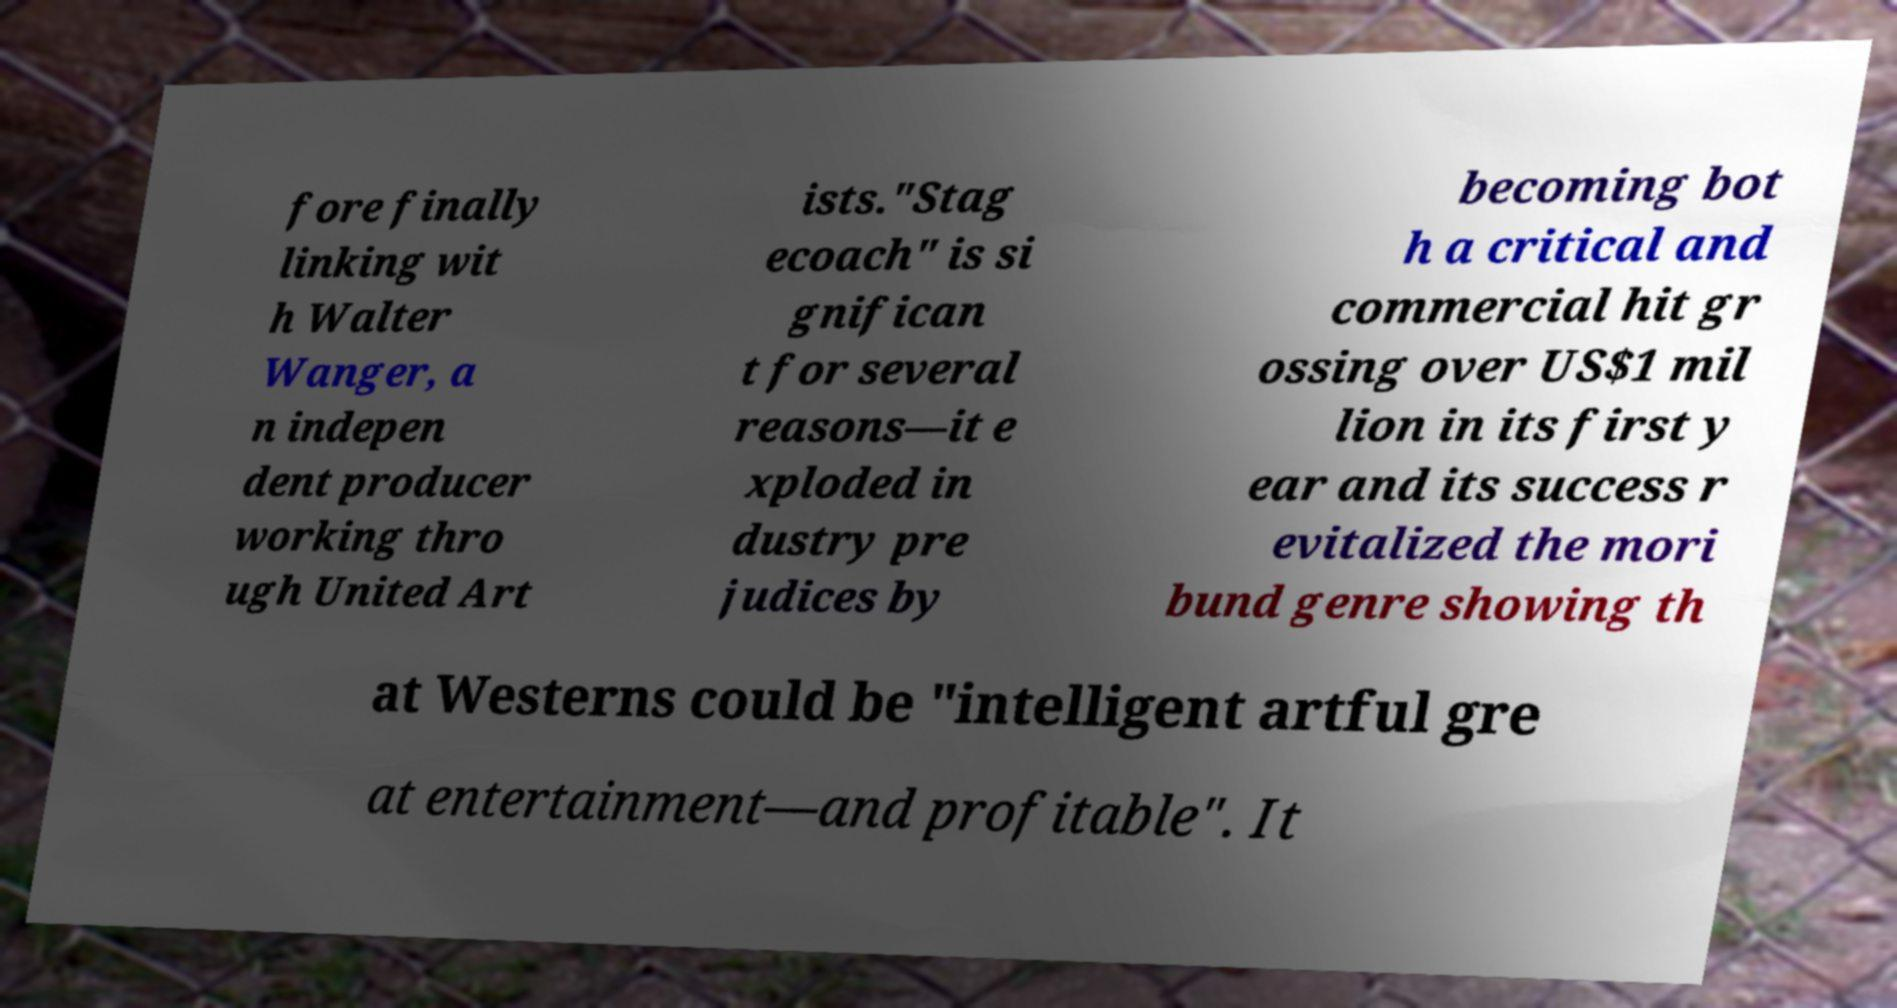For documentation purposes, I need the text within this image transcribed. Could you provide that? fore finally linking wit h Walter Wanger, a n indepen dent producer working thro ugh United Art ists."Stag ecoach" is si gnifican t for several reasons—it e xploded in dustry pre judices by becoming bot h a critical and commercial hit gr ossing over US$1 mil lion in its first y ear and its success r evitalized the mori bund genre showing th at Westerns could be "intelligent artful gre at entertainment—and profitable". It 